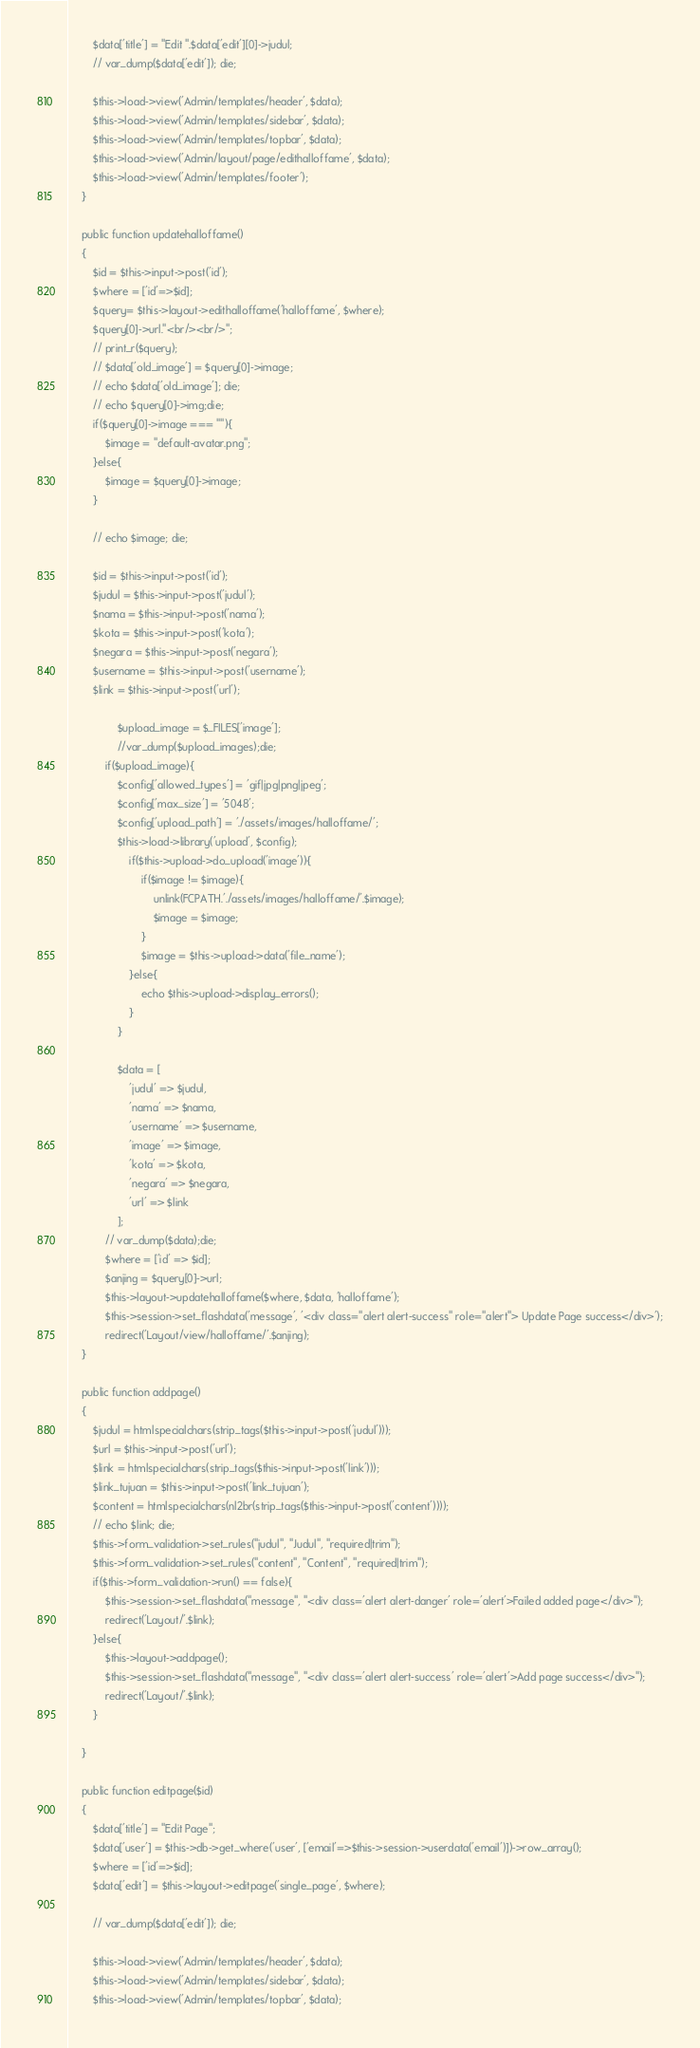Convert code to text. <code><loc_0><loc_0><loc_500><loc_500><_PHP_>        $data['title'] = "Edit ".$data['edit'][0]->judul;
        // var_dump($data['edit']); die;

        $this->load->view('Admin/templates/header', $data);
        $this->load->view('Admin/templates/sidebar', $data);
        $this->load->view('Admin/templates/topbar', $data);
        $this->load->view('Admin/layout/page/edithalloffame', $data);
        $this->load->view('Admin/templates/footer');
    }

    public function updatehalloffame()
    {
        $id = $this->input->post('id');
        $where = ['id'=>$id];
        $query= $this->layout->edithalloffame('halloffame', $where);       
        $query[0]->url."<br/><br/>";
        // print_r($query);
        // $data['old_image'] = $query[0]->image;
        // echo $data['old_image']; die;
        // echo $query[0]->img;die;
        if($query[0]->image === ""){
            $image = "default-avatar.png";
        }else{
            $image = $query[0]->image;
        }

        // echo $image; die;

        $id = $this->input->post('id');
        $judul = $this->input->post('judul');
        $nama = $this->input->post('nama');
        $kota = $this->input->post('kota');
        $negara = $this->input->post('negara');
        $username = $this->input->post('username');
        $link = $this->input->post('url');

                $upload_image = $_FILES['image'];
                //var_dump($upload_images);die;
            if($upload_image){
                $config['allowed_types'] = 'gif|jpg|png|jpeg';
                $config['max_size'] = '5048';
                $config['upload_path'] = './assets/images/halloffame/';
                $this->load->library('upload', $config);
                    if($this->upload->do_upload('image')){
                        if($image != $image){
                            unlink(FCPATH.'./assets/images/halloffame/'.$image);
                            $image = $image;
                        }
                        $image = $this->upload->data('file_name');
                    }else{
                        echo $this->upload->display_errors();
                    }
                }

                $data = [
                    'judul' => $judul,
                    'nama' => $nama,
                    'username' => $username,
                    'image' => $image,
                    'kota' => $kota,
                    'negara' => $negara,
                    'url' => $link
                ];
            // var_dump($data);die;
            $where = ['id' => $id];
            $anjing = $query[0]->url;
            $this->layout->updatehalloffame($where, $data, 'halloffame');
            $this->session->set_flashdata('message', '<div class="alert alert-success" role="alert"> Update Page success</div>');
            redirect('Layout/view/halloffame/'.$anjing);
    }

    public function addpage()
    {
        $judul = htmlspecialchars(strip_tags($this->input->post('judul')));
        $url = $this->input->post('url');
        $link = htmlspecialchars(strip_tags($this->input->post('link')));
        $link_tujuan = $this->input->post('link_tujuan');
        $content = htmlspecialchars(nl2br(strip_tags($this->input->post('content'))));
        // echo $link; die;
        $this->form_validation->set_rules("judul", "Judul", "required|trim");
        $this->form_validation->set_rules("content", "Content", "required|trim");
        if($this->form_validation->run() == false){
            $this->session->set_flashdata("message", "<div class='alert alert-danger' role='alert'>Failed added page</div>");
            redirect('Layout/'.$link);
        }else{
            $this->layout->addpage();
            $this->session->set_flashdata("message", "<div class='alert alert-success' role='alert'>Add page success</div>");
            redirect('Layout/'.$link);
        }

    }

    public function editpage($id)
    {
        $data['title'] = "Edit Page";
        $data['user'] = $this->db->get_where('user', ['email'=>$this->session->userdata('email')])->row_array();
        $where = ['id'=>$id];
        $data['edit'] = $this->layout->editpage('single_page', $where);

        // var_dump($data['edit']); die;

        $this->load->view('Admin/templates/header', $data);
        $this->load->view('Admin/templates/sidebar', $data);
        $this->load->view('Admin/templates/topbar', $data);</code> 